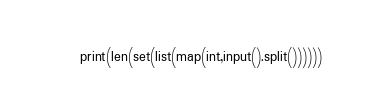<code> <loc_0><loc_0><loc_500><loc_500><_Python_>print(len(set(list(map(int,input().split())))))</code> 